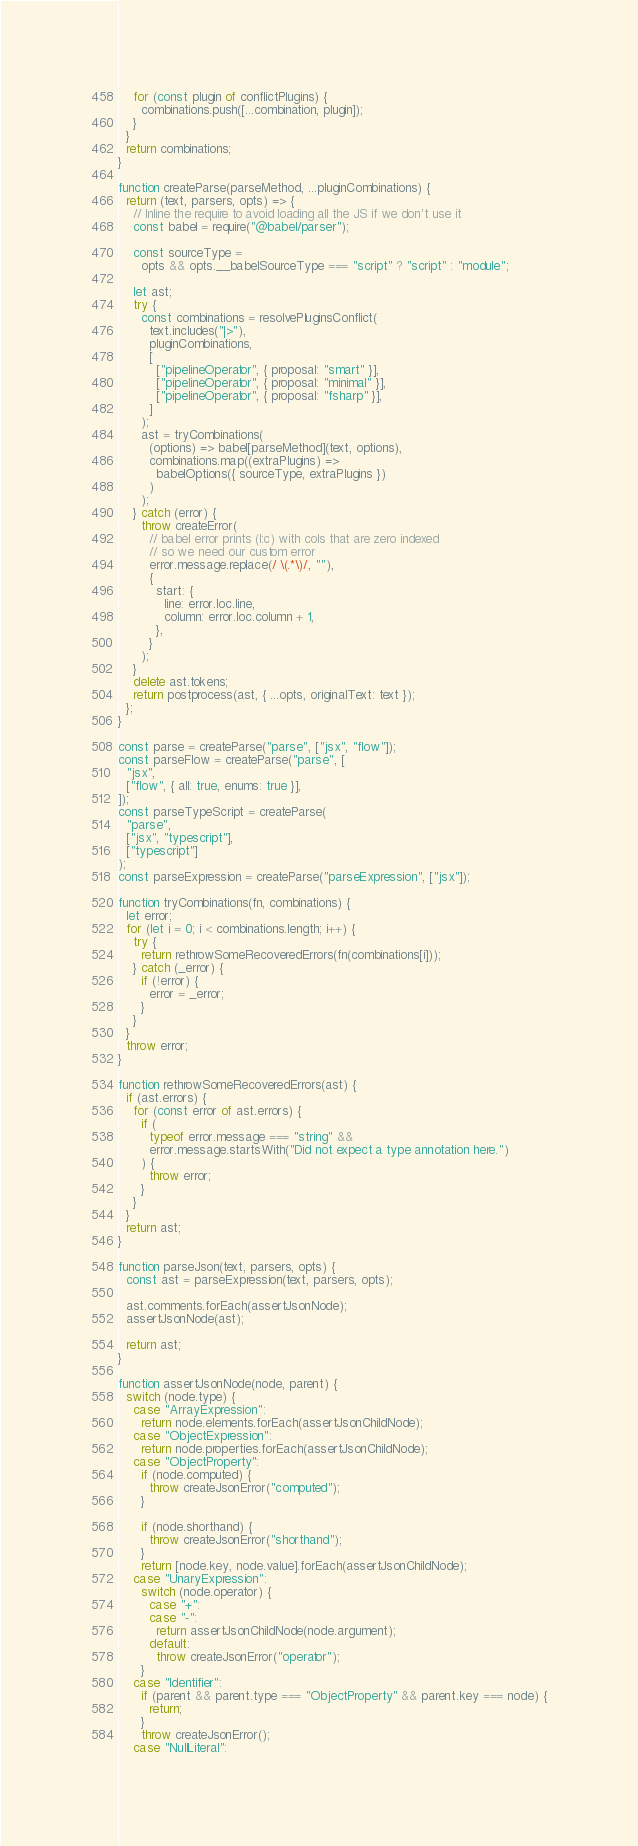<code> <loc_0><loc_0><loc_500><loc_500><_JavaScript_>    for (const plugin of conflictPlugins) {
      combinations.push([...combination, plugin]);
    }
  }
  return combinations;
}

function createParse(parseMethod, ...pluginCombinations) {
  return (text, parsers, opts) => {
    // Inline the require to avoid loading all the JS if we don't use it
    const babel = require("@babel/parser");

    const sourceType =
      opts && opts.__babelSourceType === "script" ? "script" : "module";

    let ast;
    try {
      const combinations = resolvePluginsConflict(
        text.includes("|>"),
        pluginCombinations,
        [
          ["pipelineOperator", { proposal: "smart" }],
          ["pipelineOperator", { proposal: "minimal" }],
          ["pipelineOperator", { proposal: "fsharp" }],
        ]
      );
      ast = tryCombinations(
        (options) => babel[parseMethod](text, options),
        combinations.map((extraPlugins) =>
          babelOptions({ sourceType, extraPlugins })
        )
      );
    } catch (error) {
      throw createError(
        // babel error prints (l:c) with cols that are zero indexed
        // so we need our custom error
        error.message.replace(/ \(.*\)/, ""),
        {
          start: {
            line: error.loc.line,
            column: error.loc.column + 1,
          },
        }
      );
    }
    delete ast.tokens;
    return postprocess(ast, { ...opts, originalText: text });
  };
}

const parse = createParse("parse", ["jsx", "flow"]);
const parseFlow = createParse("parse", [
  "jsx",
  ["flow", { all: true, enums: true }],
]);
const parseTypeScript = createParse(
  "parse",
  ["jsx", "typescript"],
  ["typescript"]
);
const parseExpression = createParse("parseExpression", ["jsx"]);

function tryCombinations(fn, combinations) {
  let error;
  for (let i = 0; i < combinations.length; i++) {
    try {
      return rethrowSomeRecoveredErrors(fn(combinations[i]));
    } catch (_error) {
      if (!error) {
        error = _error;
      }
    }
  }
  throw error;
}

function rethrowSomeRecoveredErrors(ast) {
  if (ast.errors) {
    for (const error of ast.errors) {
      if (
        typeof error.message === "string" &&
        error.message.startsWith("Did not expect a type annotation here.")
      ) {
        throw error;
      }
    }
  }
  return ast;
}

function parseJson(text, parsers, opts) {
  const ast = parseExpression(text, parsers, opts);

  ast.comments.forEach(assertJsonNode);
  assertJsonNode(ast);

  return ast;
}

function assertJsonNode(node, parent) {
  switch (node.type) {
    case "ArrayExpression":
      return node.elements.forEach(assertJsonChildNode);
    case "ObjectExpression":
      return node.properties.forEach(assertJsonChildNode);
    case "ObjectProperty":
      if (node.computed) {
        throw createJsonError("computed");
      }

      if (node.shorthand) {
        throw createJsonError("shorthand");
      }
      return [node.key, node.value].forEach(assertJsonChildNode);
    case "UnaryExpression":
      switch (node.operator) {
        case "+":
        case "-":
          return assertJsonChildNode(node.argument);
        default:
          throw createJsonError("operator");
      }
    case "Identifier":
      if (parent && parent.type === "ObjectProperty" && parent.key === node) {
        return;
      }
      throw createJsonError();
    case "NullLiteral":</code> 